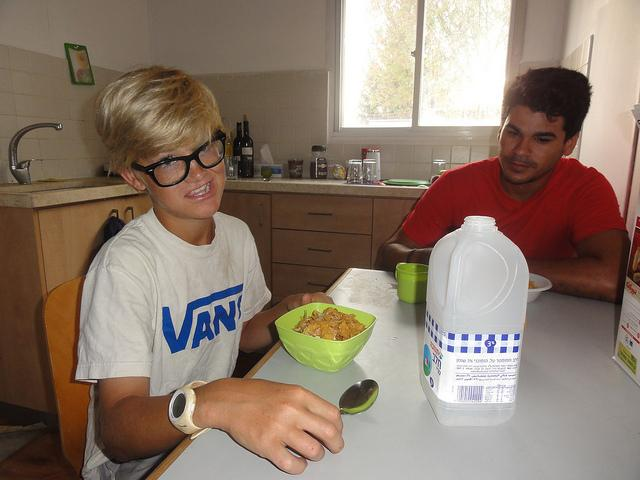What commodity has this young man exhausted? Please explain your reasoning. milk. The milk container in front of the boy is empty and there is some in his bowl. 